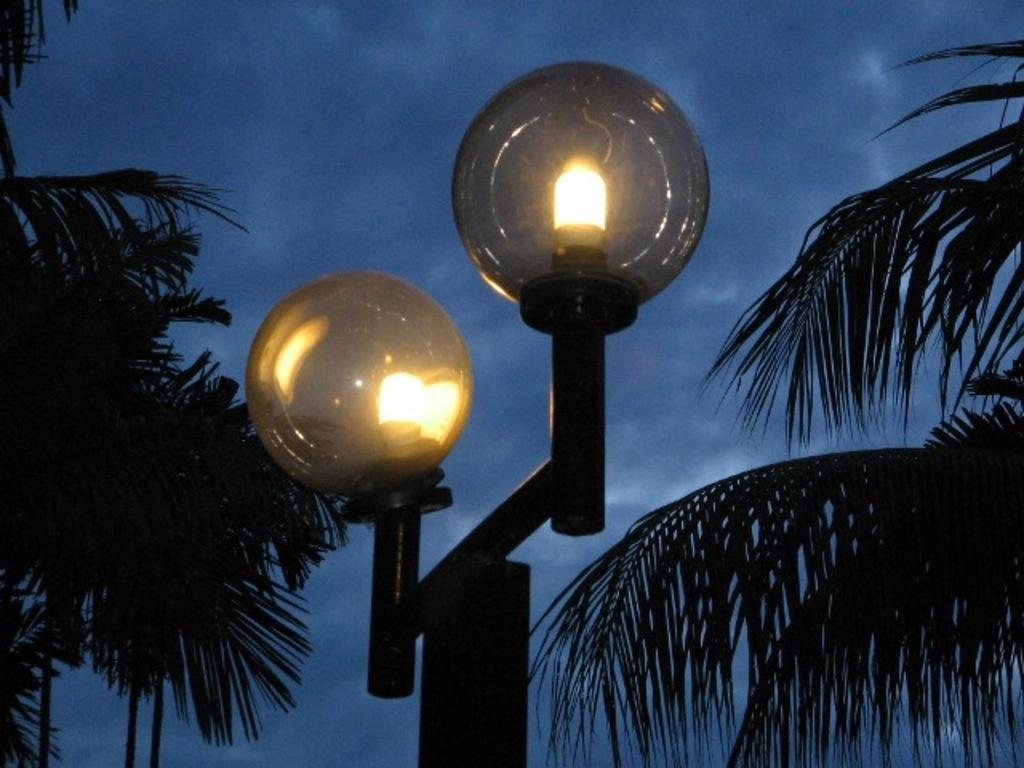Could you give a brief overview of what you see in this image? In this image, there are a few trees. We can also see a pole with some lights. We can also see the sky with clouds. 